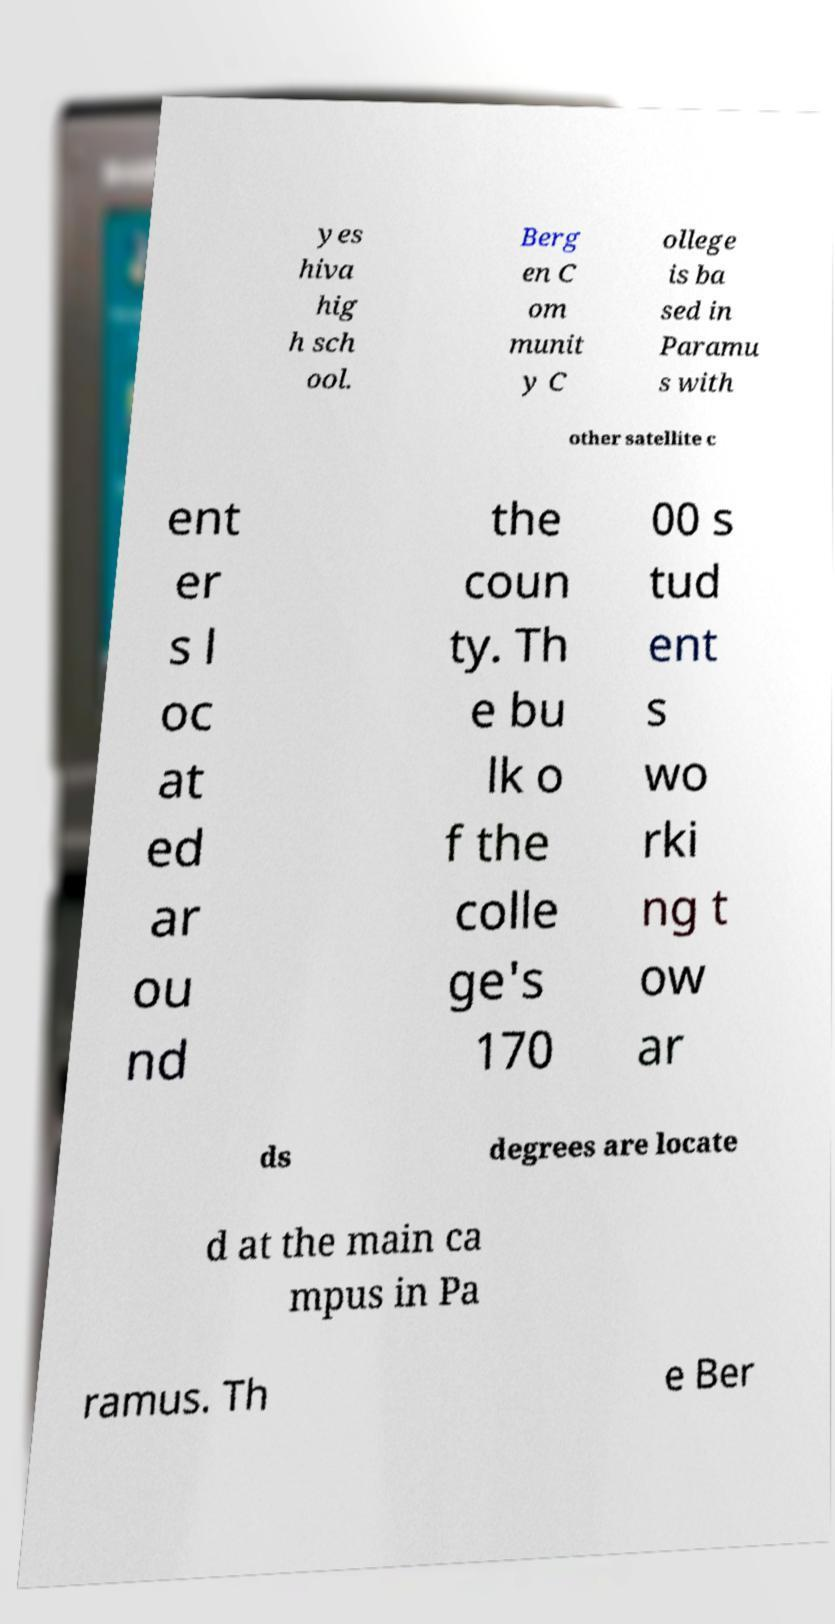Could you assist in decoding the text presented in this image and type it out clearly? yes hiva hig h sch ool. Berg en C om munit y C ollege is ba sed in Paramu s with other satellite c ent er s l oc at ed ar ou nd the coun ty. Th e bu lk o f the colle ge's 170 00 s tud ent s wo rki ng t ow ar ds degrees are locate d at the main ca mpus in Pa ramus. Th e Ber 